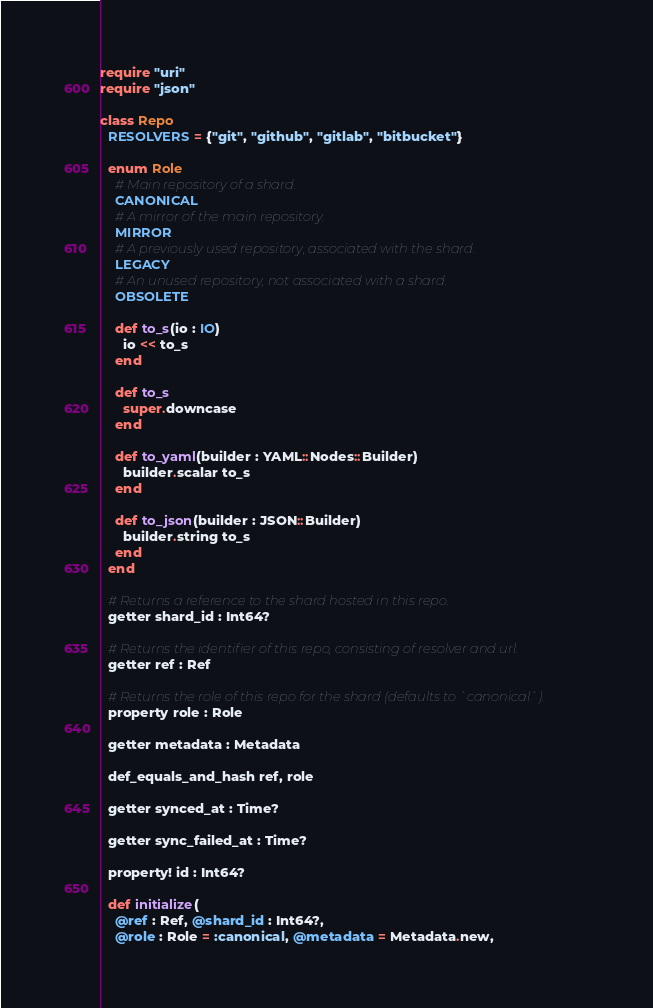Convert code to text. <code><loc_0><loc_0><loc_500><loc_500><_Crystal_>require "uri"
require "json"

class Repo
  RESOLVERS = {"git", "github", "gitlab", "bitbucket"}

  enum Role
    # Main repository of a shard.
    CANONICAL
    # A mirror of the main repository.
    MIRROR
    # A previously used repository, associated with the shard.
    LEGACY
    # An unused repository, not associated with a shard.
    OBSOLETE

    def to_s(io : IO)
      io << to_s
    end

    def to_s
      super.downcase
    end

    def to_yaml(builder : YAML::Nodes::Builder)
      builder.scalar to_s
    end

    def to_json(builder : JSON::Builder)
      builder.string to_s
    end
  end

  # Returns a reference to the shard hosted in this repo.
  getter shard_id : Int64?

  # Returns the identifier of this repo, consisting of resolver and url.
  getter ref : Ref

  # Returns the role of this repo for the shard (defaults to `canonical`).
  property role : Role

  getter metadata : Metadata

  def_equals_and_hash ref, role

  getter synced_at : Time?

  getter sync_failed_at : Time?

  property! id : Int64?

  def initialize(
    @ref : Ref, @shard_id : Int64?,
    @role : Role = :canonical, @metadata = Metadata.new,</code> 